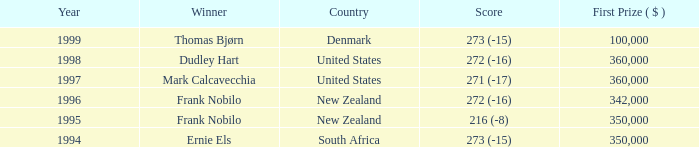In the years after frank nobilo won with a 272 (-16) score in 1996, what was the cumulative purse? None. 